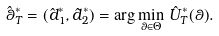Convert formula to latex. <formula><loc_0><loc_0><loc_500><loc_500>\hat { \theta } ^ { * } _ { T } = ( \hat { d } ^ { * } _ { 1 } , \hat { d } ^ { * } _ { 2 } ) = \arg \min _ { \theta \in \Theta } \, \hat { U } _ { T } ^ { * } ( \theta ) .</formula> 